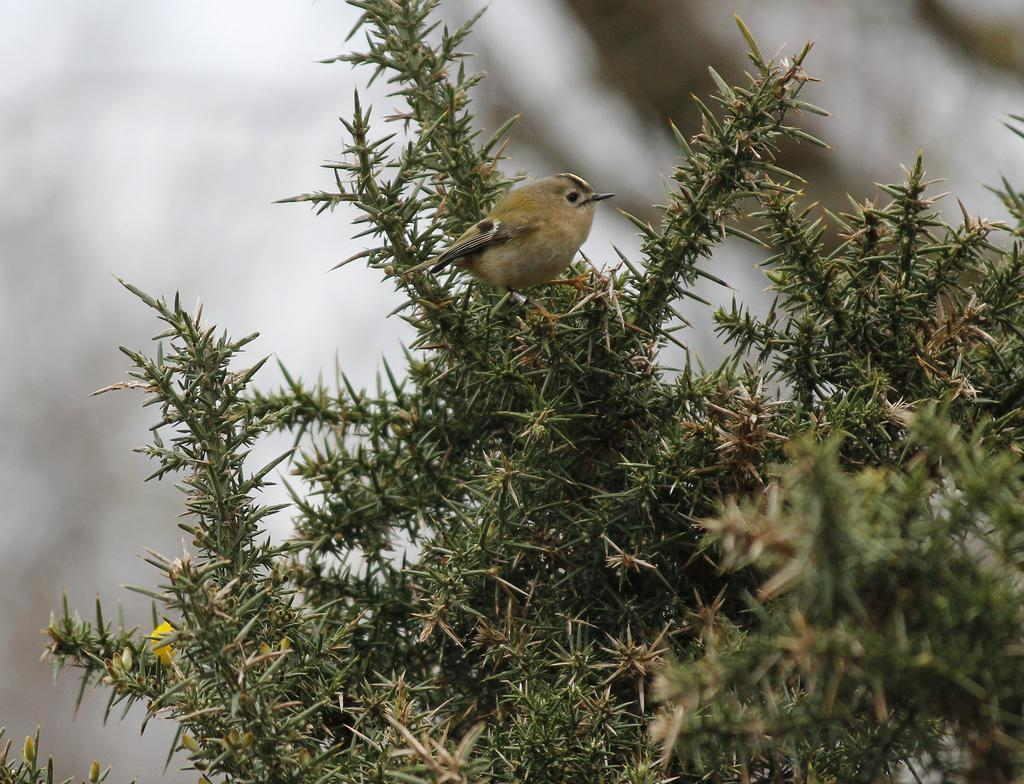What type of animal can be seen in the image? There is a bird in the image. Where is the bird located? The bird is on a tree. Can you describe the background of the image? The background of the image is blurred. What type of yoke is the bird using to fly in the image? There is no yoke present in the image, and birds do not use yokes to fly. 